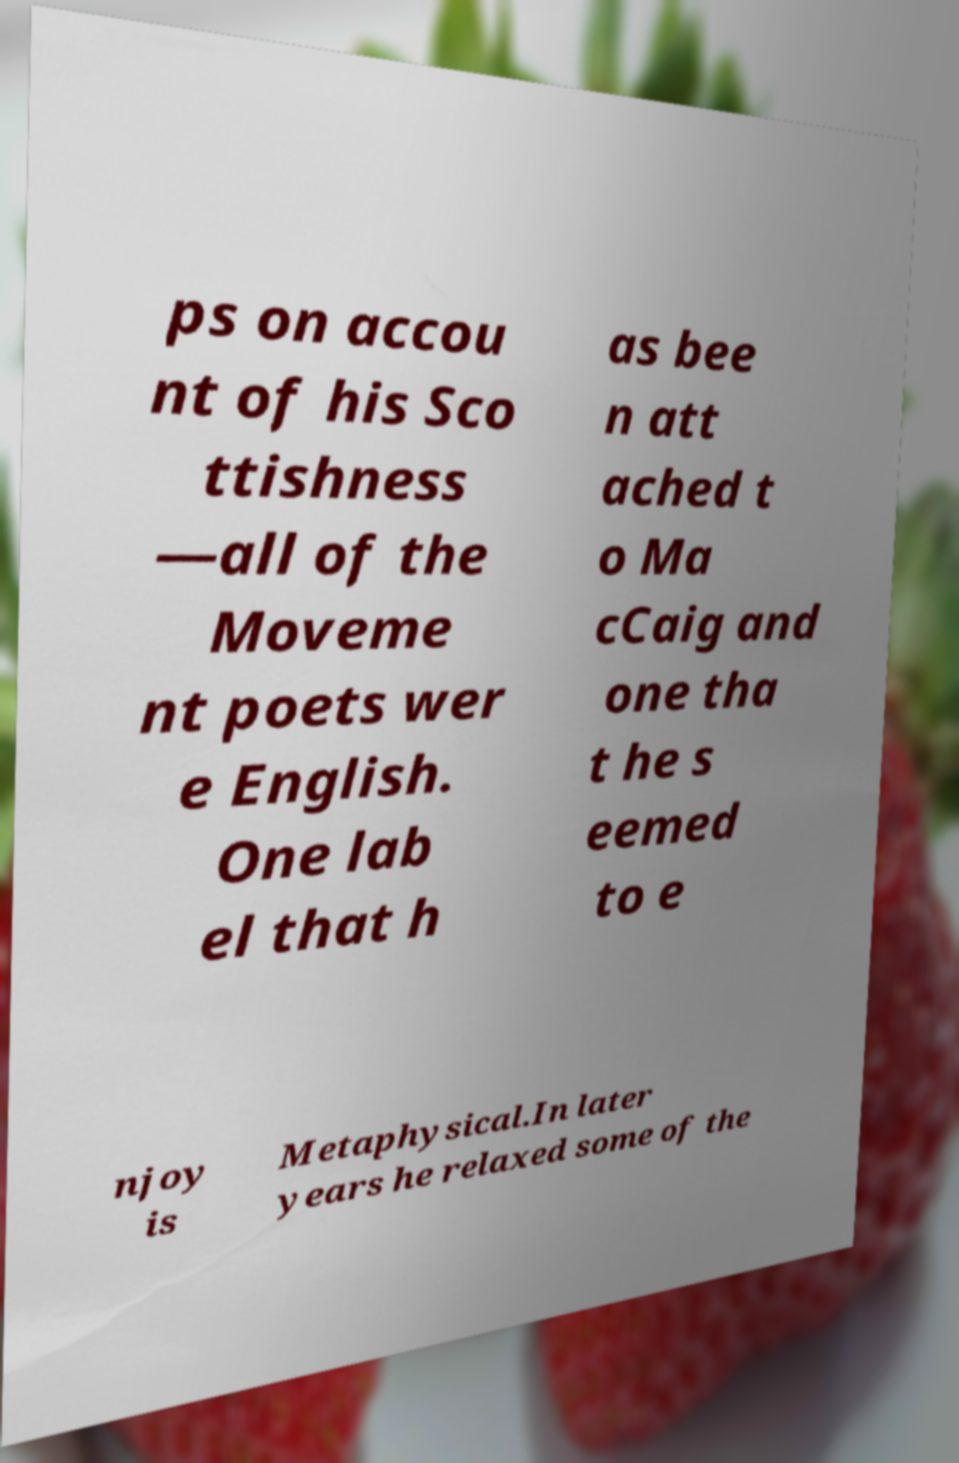Can you read and provide the text displayed in the image?This photo seems to have some interesting text. Can you extract and type it out for me? ps on accou nt of his Sco ttishness —all of the Moveme nt poets wer e English. One lab el that h as bee n att ached t o Ma cCaig and one tha t he s eemed to e njoy is Metaphysical.In later years he relaxed some of the 